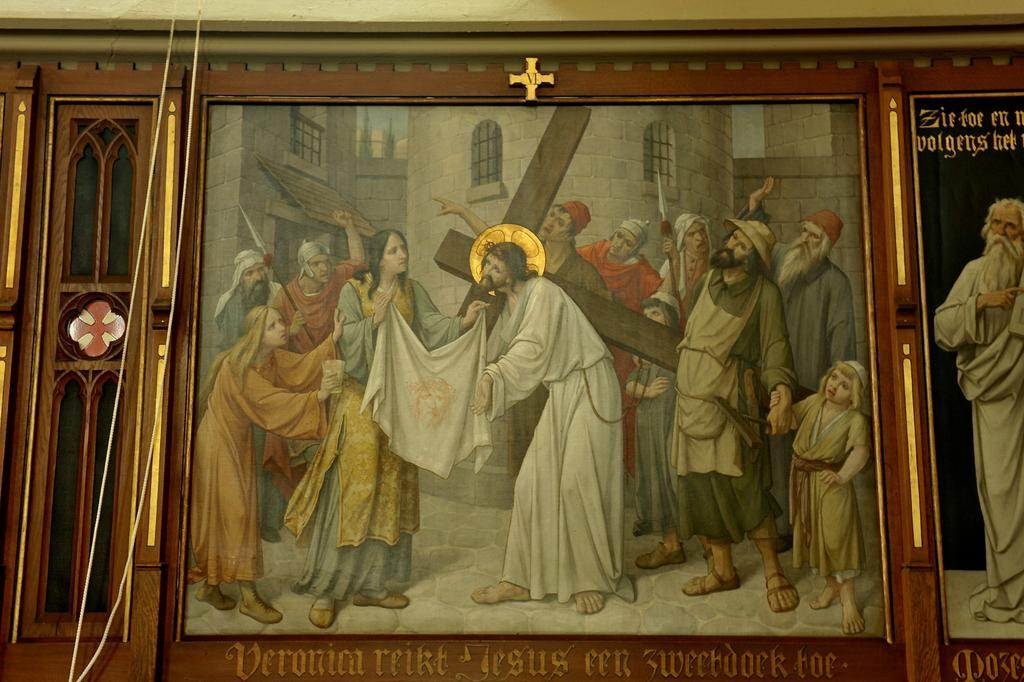What objects are present in the image that hold pictures? There are photo frames in the image that contain pictures of persons. What can be seen inside the photo frames? The photo frames contain pictures of persons. Is there any text visible in the image? Yes, there is text at the bottom of the image. How many sisters are depicted in the needlework in the image? There is no needlework or sisters present in the image; it features photo frames with pictures of persons and text at the bottom. 